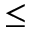<formula> <loc_0><loc_0><loc_500><loc_500>\leq</formula> 